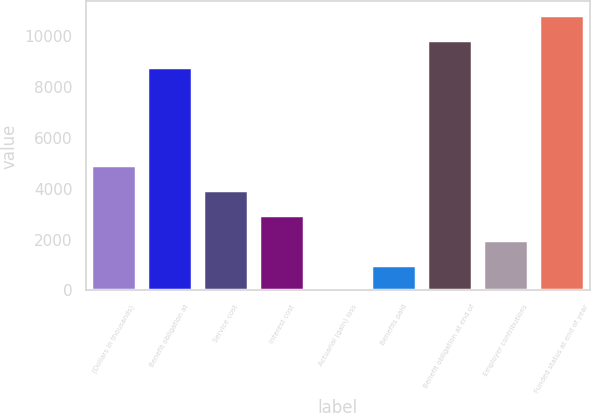<chart> <loc_0><loc_0><loc_500><loc_500><bar_chart><fcel>(Dollars in thousands)<fcel>Benefit obligation at<fcel>Service cost<fcel>Interest cost<fcel>Actuarial (gain) loss<fcel>Benefits paid<fcel>Benefit obligation at end of<fcel>Employer contributions<fcel>Funded status at end of year<nl><fcel>4916.5<fcel>8780<fcel>3933.4<fcel>2950.3<fcel>1<fcel>984.1<fcel>9832<fcel>1967.2<fcel>10815.1<nl></chart> 